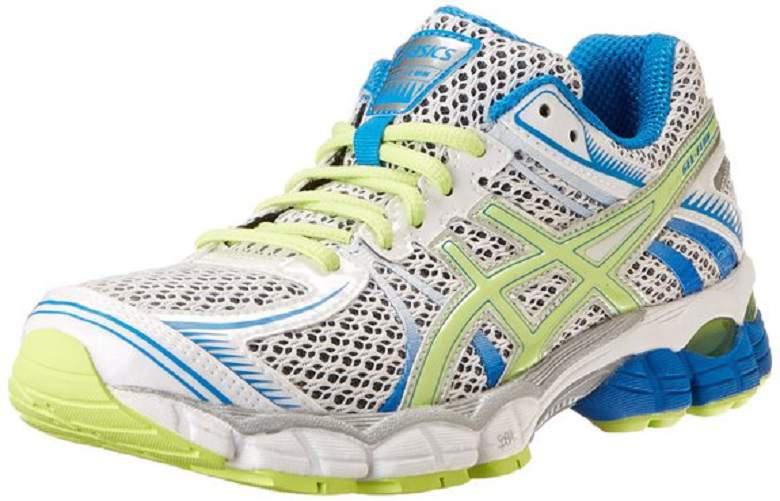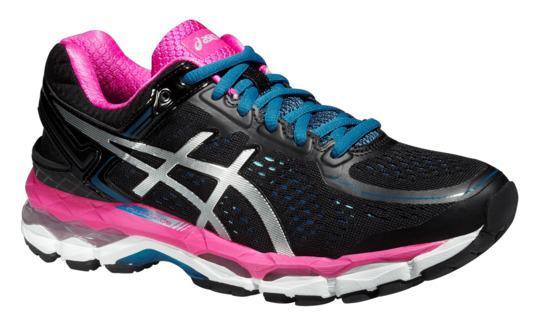The first image is the image on the left, the second image is the image on the right. Assess this claim about the two images: "Both shoes have pink shoelaces.". Correct or not? Answer yes or no. No. The first image is the image on the left, the second image is the image on the right. Analyze the images presented: Is the assertion "Left and right images each contain a single sneaker, and the pair of images are arranged heel to heel." valid? Answer yes or no. Yes. 